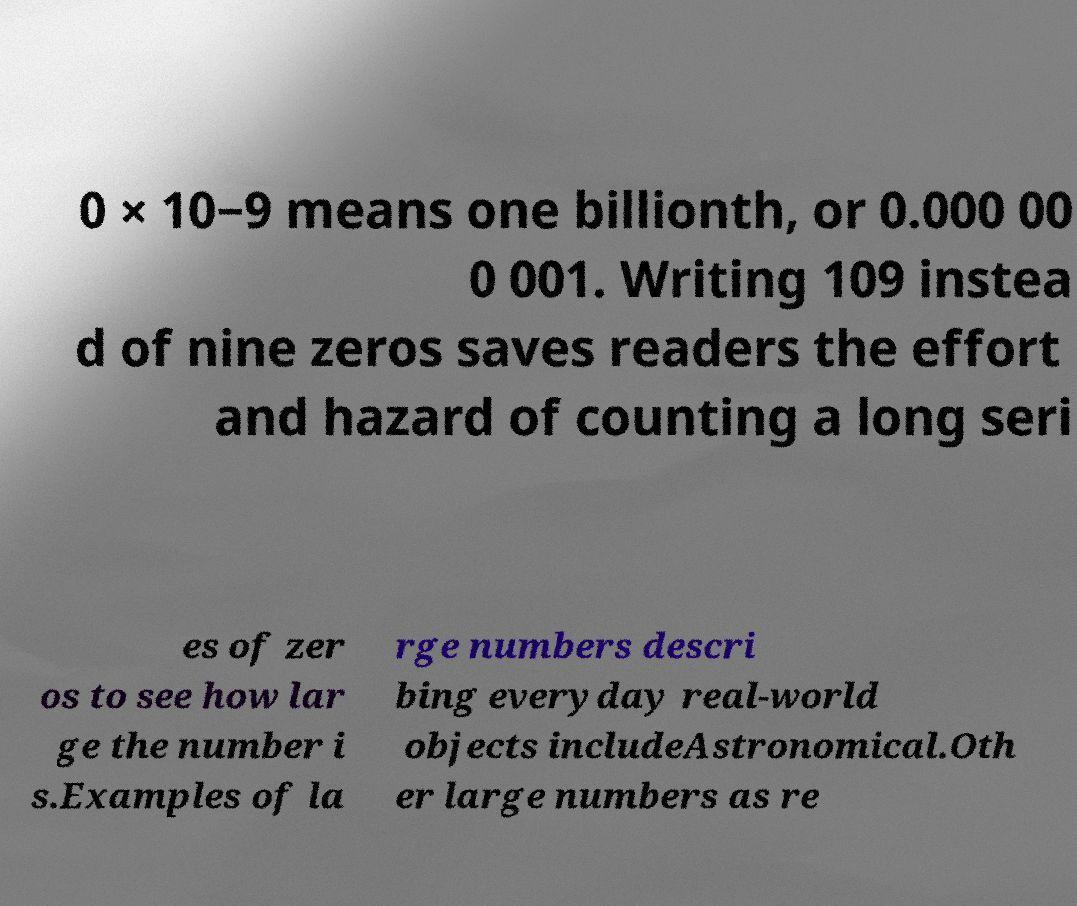Can you accurately transcribe the text from the provided image for me? 0 × 10−9 means one billionth, or 0.000 00 0 001. Writing 109 instea d of nine zeros saves readers the effort and hazard of counting a long seri es of zer os to see how lar ge the number i s.Examples of la rge numbers descri bing everyday real-world objects includeAstronomical.Oth er large numbers as re 